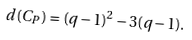Convert formula to latex. <formula><loc_0><loc_0><loc_500><loc_500>d ( C _ { P } ) = ( q - 1 ) ^ { 2 } - 3 ( q - 1 ) .</formula> 